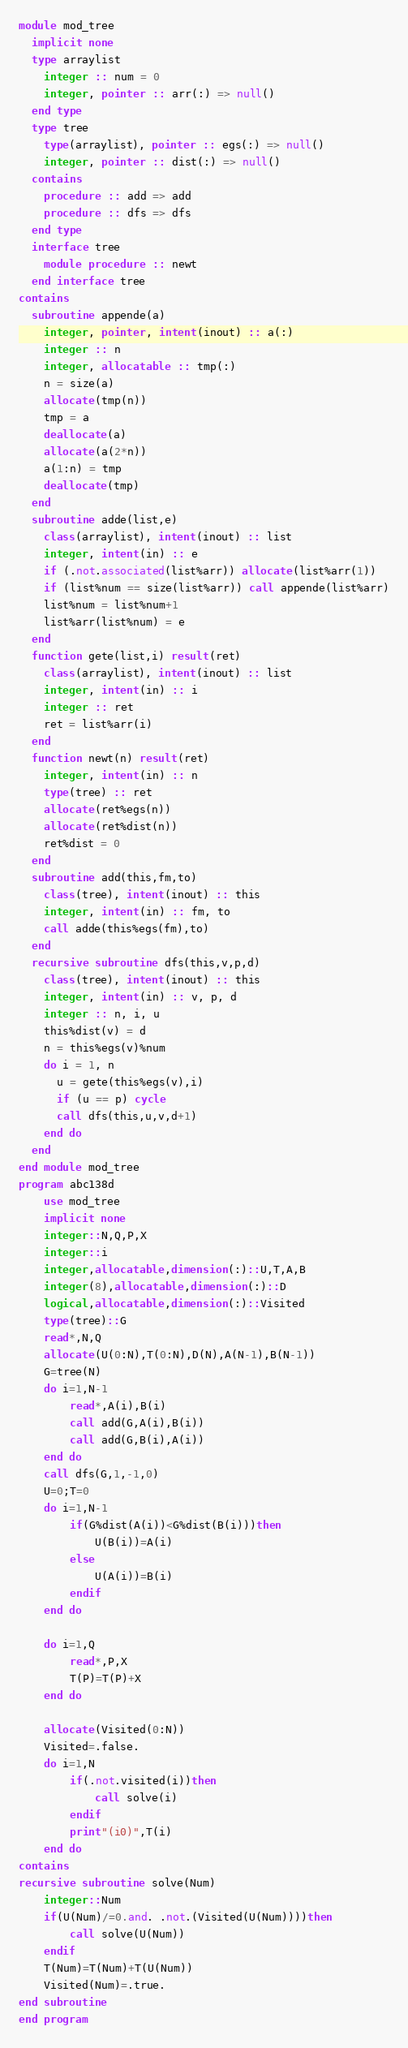<code> <loc_0><loc_0><loc_500><loc_500><_FORTRAN_>module mod_tree
  implicit none
  type arraylist
    integer :: num = 0
    integer, pointer :: arr(:) => null()
  end type
  type tree
    type(arraylist), pointer :: egs(:) => null()
    integer, pointer :: dist(:) => null()
  contains
    procedure :: add => add
    procedure :: dfs => dfs
  end type
  interface tree
    module procedure :: newt
  end interface tree
contains
  subroutine appende(a)
    integer, pointer, intent(inout) :: a(:)
    integer :: n
    integer, allocatable :: tmp(:)
    n = size(a)
    allocate(tmp(n))
    tmp = a
    deallocate(a)
    allocate(a(2*n))
    a(1:n) = tmp
    deallocate(tmp)
  end
  subroutine adde(list,e)
    class(arraylist), intent(inout) :: list
    integer, intent(in) :: e
    if (.not.associated(list%arr)) allocate(list%arr(1))
    if (list%num == size(list%arr)) call appende(list%arr)
    list%num = list%num+1
    list%arr(list%num) = e
  end
  function gete(list,i) result(ret)
    class(arraylist), intent(inout) :: list
    integer, intent(in) :: i
    integer :: ret
    ret = list%arr(i)
  end
  function newt(n) result(ret)
    integer, intent(in) :: n
    type(tree) :: ret
    allocate(ret%egs(n))
    allocate(ret%dist(n))
    ret%dist = 0
  end
  subroutine add(this,fm,to)
    class(tree), intent(inout) :: this
    integer, intent(in) :: fm, to
    call adde(this%egs(fm),to)
  end
  recursive subroutine dfs(this,v,p,d)
    class(tree), intent(inout) :: this
    integer, intent(in) :: v, p, d
    integer :: n, i, u
    this%dist(v) = d
    n = this%egs(v)%num
    do i = 1, n
      u = gete(this%egs(v),i)
      if (u == p) cycle
      call dfs(this,u,v,d+1)
    end do
  end
end module mod_tree
program abc138d
    use mod_tree
    implicit none
    integer::N,Q,P,X
    integer::i
    integer,allocatable,dimension(:)::U,T,A,B
    integer(8),allocatable,dimension(:)::D
    logical,allocatable,dimension(:)::Visited
    type(tree)::G
    read*,N,Q
    allocate(U(0:N),T(0:N),D(N),A(N-1),B(N-1))
    G=tree(N)
    do i=1,N-1
        read*,A(i),B(i)
        call add(G,A(i),B(i))
        call add(G,B(i),A(i)) 
    end do
    call dfs(G,1,-1,0)
    U=0;T=0
    do i=1,N-1
        if(G%dist(A(i))<G%dist(B(i)))then
            U(B(i))=A(i)
        else
            U(A(i))=B(i)
        endif
    end do

    do i=1,Q
        read*,P,X
        T(P)=T(P)+X
    end do
    
    allocate(Visited(0:N))
    Visited=.false.
    do i=1,N
        if(.not.visited(i))then
            call solve(i)
        endif
        print"(i0)",T(i)
    end do
contains
recursive subroutine solve(Num)
    integer::Num
    if(U(Num)/=0.and. .not.(Visited(U(Num))))then
        call solve(U(Num))
    endif
    T(Num)=T(Num)+T(U(Num))
    Visited(Num)=.true.
end subroutine
end program</code> 